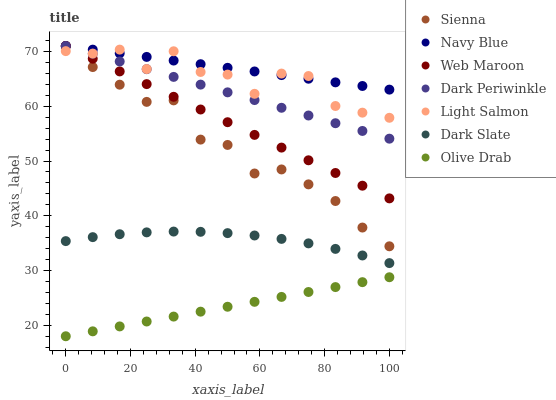Does Olive Drab have the minimum area under the curve?
Answer yes or no. Yes. Does Navy Blue have the maximum area under the curve?
Answer yes or no. Yes. Does Web Maroon have the minimum area under the curve?
Answer yes or no. No. Does Web Maroon have the maximum area under the curve?
Answer yes or no. No. Is Navy Blue the smoothest?
Answer yes or no. Yes. Is Light Salmon the roughest?
Answer yes or no. Yes. Is Web Maroon the smoothest?
Answer yes or no. No. Is Web Maroon the roughest?
Answer yes or no. No. Does Olive Drab have the lowest value?
Answer yes or no. Yes. Does Web Maroon have the lowest value?
Answer yes or no. No. Does Dark Periwinkle have the highest value?
Answer yes or no. Yes. Does Dark Slate have the highest value?
Answer yes or no. No. Is Dark Slate less than Web Maroon?
Answer yes or no. Yes. Is Sienna greater than Olive Drab?
Answer yes or no. Yes. Does Navy Blue intersect Web Maroon?
Answer yes or no. Yes. Is Navy Blue less than Web Maroon?
Answer yes or no. No. Is Navy Blue greater than Web Maroon?
Answer yes or no. No. Does Dark Slate intersect Web Maroon?
Answer yes or no. No. 